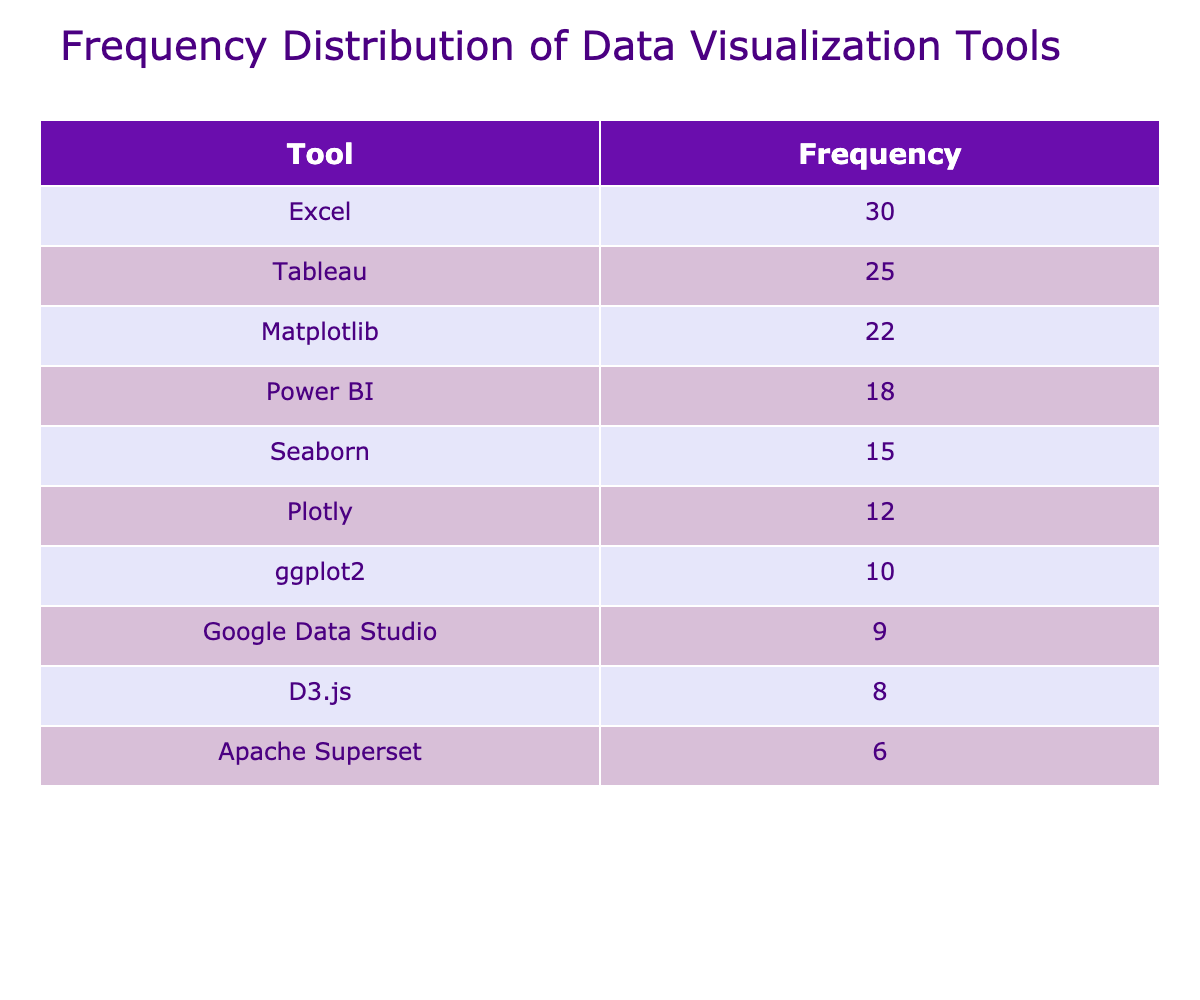What is the frequency of Excel used by forum members? The frequency value for Excel in the table is listed directly next to it, and it shows 30.
Answer: 30 Which data visualization tool has the lowest frequency? To determine this, we can look through the Frequency column and find the smallest number, which is 6 for Apache Superset.
Answer: Apache Superset What is the average frequency of the top three tools? The top three tools based on frequency are Excel (30), Tableau (25), and Matplotlib (22). Summing these frequencies gives us 30 + 25 + 22 = 77. There are 3 tools, so the average is 77 / 3 = 25.67.
Answer: 25.67 Is the frequency of D3.js greater than that of ggplot2? Looking at the table, D3.js has a frequency of 8 while ggplot2 has a frequency of 10. Since 8 is not greater than 10, the answer is no.
Answer: No What is the total frequency of all tools combined? To get the total, we need to sum up all the frequencies from each tool: 25 + 18 + 22 + 15 + 10 + 8 + 30 + 12 + 9 + 6 =  255.
Answer: 255 How many tools have a frequency of 15 or less? According to the table, the tools with frequencies of 15 or less are Seaborn (15), D3.js (8), Google Data Studio (9), and Apache Superset (6), giving us four tools in total.
Answer: 4 What is the difference in frequency between the most and least used tools? The most used tool is Excel (30) and the least used tool is Apache Superset (6). The difference is calculated as 30 - 6 = 24.
Answer: 24 Which tools have a frequency greater than 20? The tools exceeding a frequency of 20 are Excel (30), Tableau (25), and Matplotlib (22). These can be directly identified by their values in the table.
Answer: Excel, Tableau, Matplotlib Are there more tools with frequencies above 15 than tools with frequencies below 15? From examining the table, the tools with frequencies above 15 are 5 (Excel, Tableau, Matplotlib, Seaborn, Power BI) while those with frequencies below are 5 (D3.js, ggplot2, Google Data Studio, Apache Superset). Since the counts are equal, the answer is no.
Answer: No 